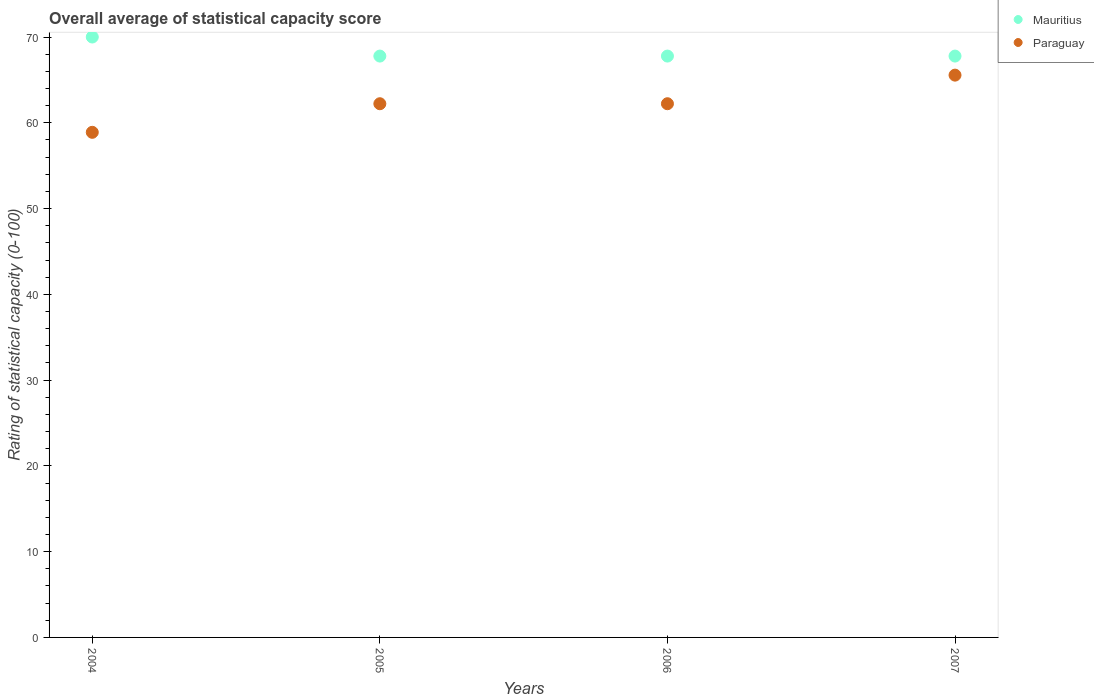How many different coloured dotlines are there?
Keep it short and to the point. 2. What is the rating of statistical capacity in Mauritius in 2004?
Keep it short and to the point. 70. Across all years, what is the minimum rating of statistical capacity in Mauritius?
Your answer should be very brief. 67.78. In which year was the rating of statistical capacity in Paraguay maximum?
Ensure brevity in your answer.  2007. What is the total rating of statistical capacity in Paraguay in the graph?
Your response must be concise. 248.89. What is the difference between the rating of statistical capacity in Paraguay in 2006 and that in 2007?
Give a very brief answer. -3.33. What is the difference between the rating of statistical capacity in Mauritius in 2004 and the rating of statistical capacity in Paraguay in 2007?
Offer a very short reply. 4.44. What is the average rating of statistical capacity in Paraguay per year?
Make the answer very short. 62.22. In the year 2007, what is the difference between the rating of statistical capacity in Paraguay and rating of statistical capacity in Mauritius?
Offer a terse response. -2.22. What is the ratio of the rating of statistical capacity in Mauritius in 2004 to that in 2006?
Provide a succinct answer. 1.03. Is the difference between the rating of statistical capacity in Paraguay in 2006 and 2007 greater than the difference between the rating of statistical capacity in Mauritius in 2006 and 2007?
Offer a very short reply. No. What is the difference between the highest and the second highest rating of statistical capacity in Paraguay?
Provide a succinct answer. 3.33. What is the difference between the highest and the lowest rating of statistical capacity in Paraguay?
Offer a very short reply. 6.67. Is the rating of statistical capacity in Mauritius strictly greater than the rating of statistical capacity in Paraguay over the years?
Ensure brevity in your answer.  Yes. What is the difference between two consecutive major ticks on the Y-axis?
Offer a very short reply. 10. Are the values on the major ticks of Y-axis written in scientific E-notation?
Give a very brief answer. No. Does the graph contain any zero values?
Ensure brevity in your answer.  No. Does the graph contain grids?
Keep it short and to the point. No. Where does the legend appear in the graph?
Your response must be concise. Top right. How many legend labels are there?
Ensure brevity in your answer.  2. How are the legend labels stacked?
Provide a short and direct response. Vertical. What is the title of the graph?
Offer a terse response. Overall average of statistical capacity score. What is the label or title of the X-axis?
Your response must be concise. Years. What is the label or title of the Y-axis?
Give a very brief answer. Rating of statistical capacity (0-100). What is the Rating of statistical capacity (0-100) of Paraguay in 2004?
Provide a short and direct response. 58.89. What is the Rating of statistical capacity (0-100) of Mauritius in 2005?
Your answer should be compact. 67.78. What is the Rating of statistical capacity (0-100) in Paraguay in 2005?
Ensure brevity in your answer.  62.22. What is the Rating of statistical capacity (0-100) of Mauritius in 2006?
Your answer should be compact. 67.78. What is the Rating of statistical capacity (0-100) of Paraguay in 2006?
Your answer should be compact. 62.22. What is the Rating of statistical capacity (0-100) in Mauritius in 2007?
Provide a succinct answer. 67.78. What is the Rating of statistical capacity (0-100) of Paraguay in 2007?
Your response must be concise. 65.56. Across all years, what is the maximum Rating of statistical capacity (0-100) in Paraguay?
Make the answer very short. 65.56. Across all years, what is the minimum Rating of statistical capacity (0-100) in Mauritius?
Give a very brief answer. 67.78. Across all years, what is the minimum Rating of statistical capacity (0-100) of Paraguay?
Offer a terse response. 58.89. What is the total Rating of statistical capacity (0-100) in Mauritius in the graph?
Your response must be concise. 273.33. What is the total Rating of statistical capacity (0-100) in Paraguay in the graph?
Offer a very short reply. 248.89. What is the difference between the Rating of statistical capacity (0-100) of Mauritius in 2004 and that in 2005?
Offer a very short reply. 2.22. What is the difference between the Rating of statistical capacity (0-100) of Paraguay in 2004 and that in 2005?
Give a very brief answer. -3.33. What is the difference between the Rating of statistical capacity (0-100) of Mauritius in 2004 and that in 2006?
Ensure brevity in your answer.  2.22. What is the difference between the Rating of statistical capacity (0-100) in Paraguay in 2004 and that in 2006?
Your answer should be very brief. -3.33. What is the difference between the Rating of statistical capacity (0-100) of Mauritius in 2004 and that in 2007?
Give a very brief answer. 2.22. What is the difference between the Rating of statistical capacity (0-100) in Paraguay in 2004 and that in 2007?
Your answer should be compact. -6.67. What is the difference between the Rating of statistical capacity (0-100) of Mauritius in 2005 and that in 2006?
Your answer should be compact. 0. What is the difference between the Rating of statistical capacity (0-100) in Paraguay in 2005 and that in 2006?
Ensure brevity in your answer.  0. What is the difference between the Rating of statistical capacity (0-100) in Mauritius in 2006 and that in 2007?
Your response must be concise. 0. What is the difference between the Rating of statistical capacity (0-100) in Mauritius in 2004 and the Rating of statistical capacity (0-100) in Paraguay in 2005?
Offer a very short reply. 7.78. What is the difference between the Rating of statistical capacity (0-100) in Mauritius in 2004 and the Rating of statistical capacity (0-100) in Paraguay in 2006?
Ensure brevity in your answer.  7.78. What is the difference between the Rating of statistical capacity (0-100) of Mauritius in 2004 and the Rating of statistical capacity (0-100) of Paraguay in 2007?
Your response must be concise. 4.44. What is the difference between the Rating of statistical capacity (0-100) of Mauritius in 2005 and the Rating of statistical capacity (0-100) of Paraguay in 2006?
Keep it short and to the point. 5.56. What is the difference between the Rating of statistical capacity (0-100) in Mauritius in 2005 and the Rating of statistical capacity (0-100) in Paraguay in 2007?
Ensure brevity in your answer.  2.22. What is the difference between the Rating of statistical capacity (0-100) in Mauritius in 2006 and the Rating of statistical capacity (0-100) in Paraguay in 2007?
Give a very brief answer. 2.22. What is the average Rating of statistical capacity (0-100) in Mauritius per year?
Your answer should be compact. 68.33. What is the average Rating of statistical capacity (0-100) in Paraguay per year?
Offer a terse response. 62.22. In the year 2004, what is the difference between the Rating of statistical capacity (0-100) in Mauritius and Rating of statistical capacity (0-100) in Paraguay?
Offer a very short reply. 11.11. In the year 2005, what is the difference between the Rating of statistical capacity (0-100) of Mauritius and Rating of statistical capacity (0-100) of Paraguay?
Offer a very short reply. 5.56. In the year 2006, what is the difference between the Rating of statistical capacity (0-100) in Mauritius and Rating of statistical capacity (0-100) in Paraguay?
Ensure brevity in your answer.  5.56. In the year 2007, what is the difference between the Rating of statistical capacity (0-100) of Mauritius and Rating of statistical capacity (0-100) of Paraguay?
Give a very brief answer. 2.22. What is the ratio of the Rating of statistical capacity (0-100) in Mauritius in 2004 to that in 2005?
Provide a short and direct response. 1.03. What is the ratio of the Rating of statistical capacity (0-100) of Paraguay in 2004 to that in 2005?
Offer a very short reply. 0.95. What is the ratio of the Rating of statistical capacity (0-100) in Mauritius in 2004 to that in 2006?
Give a very brief answer. 1.03. What is the ratio of the Rating of statistical capacity (0-100) of Paraguay in 2004 to that in 2006?
Offer a terse response. 0.95. What is the ratio of the Rating of statistical capacity (0-100) of Mauritius in 2004 to that in 2007?
Your answer should be very brief. 1.03. What is the ratio of the Rating of statistical capacity (0-100) of Paraguay in 2004 to that in 2007?
Give a very brief answer. 0.9. What is the ratio of the Rating of statistical capacity (0-100) of Mauritius in 2005 to that in 2006?
Offer a terse response. 1. What is the ratio of the Rating of statistical capacity (0-100) in Paraguay in 2005 to that in 2006?
Your answer should be compact. 1. What is the ratio of the Rating of statistical capacity (0-100) in Mauritius in 2005 to that in 2007?
Your response must be concise. 1. What is the ratio of the Rating of statistical capacity (0-100) in Paraguay in 2005 to that in 2007?
Your response must be concise. 0.95. What is the ratio of the Rating of statistical capacity (0-100) in Paraguay in 2006 to that in 2007?
Provide a succinct answer. 0.95. What is the difference between the highest and the second highest Rating of statistical capacity (0-100) in Mauritius?
Make the answer very short. 2.22. What is the difference between the highest and the second highest Rating of statistical capacity (0-100) of Paraguay?
Give a very brief answer. 3.33. What is the difference between the highest and the lowest Rating of statistical capacity (0-100) in Mauritius?
Provide a short and direct response. 2.22. What is the difference between the highest and the lowest Rating of statistical capacity (0-100) of Paraguay?
Ensure brevity in your answer.  6.67. 